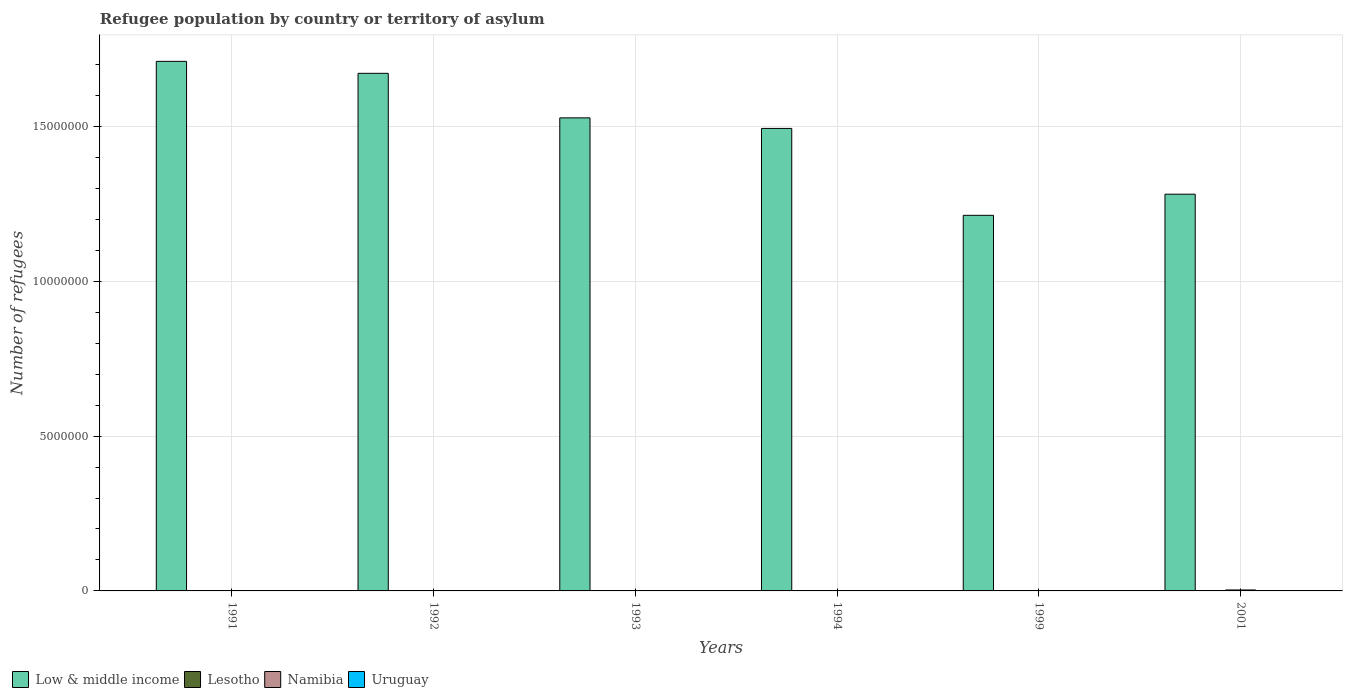Are the number of bars on each tick of the X-axis equal?
Your response must be concise. Yes. How many bars are there on the 1st tick from the left?
Give a very brief answer. 4. How many bars are there on the 3rd tick from the right?
Make the answer very short. 4. What is the label of the 3rd group of bars from the left?
Make the answer very short. 1993. In how many cases, is the number of bars for a given year not equal to the number of legend labels?
Your response must be concise. 0. What is the number of refugees in Low & middle income in 1991?
Make the answer very short. 1.71e+07. Across all years, what is the maximum number of refugees in Uruguay?
Your response must be concise. 138. Across all years, what is the minimum number of refugees in Low & middle income?
Provide a short and direct response. 1.21e+07. In which year was the number of refugees in Namibia maximum?
Your answer should be compact. 2001. In which year was the number of refugees in Low & middle income minimum?
Ensure brevity in your answer.  1999. What is the total number of refugees in Low & middle income in the graph?
Your answer should be very brief. 8.90e+07. What is the difference between the number of refugees in Uruguay in 1993 and that in 1994?
Ensure brevity in your answer.  25. What is the difference between the number of refugees in Low & middle income in 2001 and the number of refugees in Namibia in 1991?
Provide a short and direct response. 1.28e+07. What is the average number of refugees in Lesotho per year?
Give a very brief answer. 82.5. In the year 1993, what is the difference between the number of refugees in Namibia and number of refugees in Low & middle income?
Keep it short and to the point. -1.53e+07. In how many years, is the number of refugees in Lesotho greater than 3000000?
Make the answer very short. 0. What is the ratio of the number of refugees in Namibia in 1993 to that in 1999?
Your answer should be very brief. 0.08. Is the number of refugees in Namibia in 1993 less than that in 2001?
Provide a short and direct response. Yes. Is the difference between the number of refugees in Namibia in 1993 and 1999 greater than the difference between the number of refugees in Low & middle income in 1993 and 1999?
Offer a terse response. No. What is the difference between the highest and the lowest number of refugees in Uruguay?
Ensure brevity in your answer.  57. Is the sum of the number of refugees in Lesotho in 1992 and 1994 greater than the maximum number of refugees in Low & middle income across all years?
Your response must be concise. No. Is it the case that in every year, the sum of the number of refugees in Namibia and number of refugees in Lesotho is greater than the sum of number of refugees in Uruguay and number of refugees in Low & middle income?
Offer a very short reply. No. What does the 1st bar from the left in 2001 represents?
Keep it short and to the point. Low & middle income. What does the 3rd bar from the right in 1993 represents?
Offer a very short reply. Lesotho. Is it the case that in every year, the sum of the number of refugees in Lesotho and number of refugees in Low & middle income is greater than the number of refugees in Namibia?
Provide a succinct answer. Yes. How many years are there in the graph?
Offer a very short reply. 6. What is the difference between two consecutive major ticks on the Y-axis?
Give a very brief answer. 5.00e+06. Does the graph contain any zero values?
Give a very brief answer. No. What is the title of the graph?
Your answer should be very brief. Refugee population by country or territory of asylum. Does "United States" appear as one of the legend labels in the graph?
Keep it short and to the point. No. What is the label or title of the X-axis?
Give a very brief answer. Years. What is the label or title of the Y-axis?
Keep it short and to the point. Number of refugees. What is the Number of refugees in Low & middle income in 1991?
Offer a terse response. 1.71e+07. What is the Number of refugees in Lesotho in 1991?
Your answer should be very brief. 220. What is the Number of refugees in Namibia in 1991?
Ensure brevity in your answer.  136. What is the Number of refugees of Low & middle income in 1992?
Your response must be concise. 1.67e+07. What is the Number of refugees of Lesotho in 1992?
Your answer should be very brief. 117. What is the Number of refugees of Namibia in 1992?
Provide a short and direct response. 171. What is the Number of refugees in Uruguay in 1992?
Offer a terse response. 90. What is the Number of refugees of Low & middle income in 1993?
Make the answer very short. 1.53e+07. What is the Number of refugees in Namibia in 1993?
Give a very brief answer. 585. What is the Number of refugees in Uruguay in 1993?
Provide a short and direct response. 138. What is the Number of refugees of Low & middle income in 1994?
Make the answer very short. 1.49e+07. What is the Number of refugees in Namibia in 1994?
Ensure brevity in your answer.  1144. What is the Number of refugees in Uruguay in 1994?
Provide a short and direct response. 113. What is the Number of refugees in Low & middle income in 1999?
Give a very brief answer. 1.21e+07. What is the Number of refugees of Lesotho in 1999?
Provide a short and direct response. 1. What is the Number of refugees of Namibia in 1999?
Offer a very short reply. 7612. What is the Number of refugees in Uruguay in 1999?
Keep it short and to the point. 87. What is the Number of refugees of Low & middle income in 2001?
Provide a succinct answer. 1.28e+07. What is the Number of refugees of Lesotho in 2001?
Keep it short and to the point. 39. What is the Number of refugees in Namibia in 2001?
Offer a very short reply. 3.09e+04. What is the Number of refugees in Uruguay in 2001?
Make the answer very short. 90. Across all years, what is the maximum Number of refugees of Low & middle income?
Keep it short and to the point. 1.71e+07. Across all years, what is the maximum Number of refugees of Lesotho?
Provide a short and direct response. 220. Across all years, what is the maximum Number of refugees of Namibia?
Offer a very short reply. 3.09e+04. Across all years, what is the maximum Number of refugees of Uruguay?
Offer a very short reply. 138. Across all years, what is the minimum Number of refugees in Low & middle income?
Ensure brevity in your answer.  1.21e+07. Across all years, what is the minimum Number of refugees of Lesotho?
Provide a succinct answer. 1. Across all years, what is the minimum Number of refugees in Namibia?
Provide a short and direct response. 136. What is the total Number of refugees in Low & middle income in the graph?
Offer a very short reply. 8.90e+07. What is the total Number of refugees of Lesotho in the graph?
Make the answer very short. 495. What is the total Number of refugees in Namibia in the graph?
Keep it short and to the point. 4.05e+04. What is the total Number of refugees in Uruguay in the graph?
Your response must be concise. 599. What is the difference between the Number of refugees in Low & middle income in 1991 and that in 1992?
Your answer should be compact. 3.87e+05. What is the difference between the Number of refugees of Lesotho in 1991 and that in 1992?
Your answer should be compact. 103. What is the difference between the Number of refugees in Namibia in 1991 and that in 1992?
Ensure brevity in your answer.  -35. What is the difference between the Number of refugees in Uruguay in 1991 and that in 1992?
Keep it short and to the point. -9. What is the difference between the Number of refugees of Low & middle income in 1991 and that in 1993?
Your answer should be very brief. 1.82e+06. What is the difference between the Number of refugees of Lesotho in 1991 and that in 1993?
Your answer should be very brief. 160. What is the difference between the Number of refugees in Namibia in 1991 and that in 1993?
Your answer should be compact. -449. What is the difference between the Number of refugees in Uruguay in 1991 and that in 1993?
Your answer should be very brief. -57. What is the difference between the Number of refugees of Low & middle income in 1991 and that in 1994?
Make the answer very short. 2.17e+06. What is the difference between the Number of refugees of Lesotho in 1991 and that in 1994?
Offer a very short reply. 162. What is the difference between the Number of refugees of Namibia in 1991 and that in 1994?
Provide a short and direct response. -1008. What is the difference between the Number of refugees in Uruguay in 1991 and that in 1994?
Your answer should be compact. -32. What is the difference between the Number of refugees of Low & middle income in 1991 and that in 1999?
Your response must be concise. 4.97e+06. What is the difference between the Number of refugees of Lesotho in 1991 and that in 1999?
Give a very brief answer. 219. What is the difference between the Number of refugees of Namibia in 1991 and that in 1999?
Offer a very short reply. -7476. What is the difference between the Number of refugees in Uruguay in 1991 and that in 1999?
Make the answer very short. -6. What is the difference between the Number of refugees in Low & middle income in 1991 and that in 2001?
Provide a short and direct response. 4.29e+06. What is the difference between the Number of refugees of Lesotho in 1991 and that in 2001?
Ensure brevity in your answer.  181. What is the difference between the Number of refugees of Namibia in 1991 and that in 2001?
Your answer should be compact. -3.07e+04. What is the difference between the Number of refugees of Uruguay in 1991 and that in 2001?
Keep it short and to the point. -9. What is the difference between the Number of refugees of Low & middle income in 1992 and that in 1993?
Provide a short and direct response. 1.44e+06. What is the difference between the Number of refugees of Lesotho in 1992 and that in 1993?
Make the answer very short. 57. What is the difference between the Number of refugees of Namibia in 1992 and that in 1993?
Ensure brevity in your answer.  -414. What is the difference between the Number of refugees in Uruguay in 1992 and that in 1993?
Give a very brief answer. -48. What is the difference between the Number of refugees in Low & middle income in 1992 and that in 1994?
Provide a succinct answer. 1.78e+06. What is the difference between the Number of refugees in Namibia in 1992 and that in 1994?
Provide a short and direct response. -973. What is the difference between the Number of refugees in Low & middle income in 1992 and that in 1999?
Provide a succinct answer. 4.59e+06. What is the difference between the Number of refugees of Lesotho in 1992 and that in 1999?
Provide a short and direct response. 116. What is the difference between the Number of refugees in Namibia in 1992 and that in 1999?
Your response must be concise. -7441. What is the difference between the Number of refugees in Low & middle income in 1992 and that in 2001?
Make the answer very short. 3.90e+06. What is the difference between the Number of refugees in Namibia in 1992 and that in 2001?
Make the answer very short. -3.07e+04. What is the difference between the Number of refugees in Low & middle income in 1993 and that in 1994?
Your answer should be compact. 3.41e+05. What is the difference between the Number of refugees in Lesotho in 1993 and that in 1994?
Your response must be concise. 2. What is the difference between the Number of refugees of Namibia in 1993 and that in 1994?
Provide a short and direct response. -559. What is the difference between the Number of refugees of Uruguay in 1993 and that in 1994?
Your answer should be compact. 25. What is the difference between the Number of refugees in Low & middle income in 1993 and that in 1999?
Offer a terse response. 3.15e+06. What is the difference between the Number of refugees in Lesotho in 1993 and that in 1999?
Your response must be concise. 59. What is the difference between the Number of refugees in Namibia in 1993 and that in 1999?
Offer a terse response. -7027. What is the difference between the Number of refugees in Low & middle income in 1993 and that in 2001?
Keep it short and to the point. 2.46e+06. What is the difference between the Number of refugees in Lesotho in 1993 and that in 2001?
Ensure brevity in your answer.  21. What is the difference between the Number of refugees of Namibia in 1993 and that in 2001?
Your response must be concise. -3.03e+04. What is the difference between the Number of refugees of Low & middle income in 1994 and that in 1999?
Your response must be concise. 2.81e+06. What is the difference between the Number of refugees of Lesotho in 1994 and that in 1999?
Your answer should be compact. 57. What is the difference between the Number of refugees of Namibia in 1994 and that in 1999?
Give a very brief answer. -6468. What is the difference between the Number of refugees in Uruguay in 1994 and that in 1999?
Make the answer very short. 26. What is the difference between the Number of refugees in Low & middle income in 1994 and that in 2001?
Ensure brevity in your answer.  2.12e+06. What is the difference between the Number of refugees of Namibia in 1994 and that in 2001?
Make the answer very short. -2.97e+04. What is the difference between the Number of refugees of Low & middle income in 1999 and that in 2001?
Offer a very short reply. -6.82e+05. What is the difference between the Number of refugees in Lesotho in 1999 and that in 2001?
Offer a terse response. -38. What is the difference between the Number of refugees in Namibia in 1999 and that in 2001?
Provide a short and direct response. -2.33e+04. What is the difference between the Number of refugees in Low & middle income in 1991 and the Number of refugees in Lesotho in 1992?
Keep it short and to the point. 1.71e+07. What is the difference between the Number of refugees of Low & middle income in 1991 and the Number of refugees of Namibia in 1992?
Your response must be concise. 1.71e+07. What is the difference between the Number of refugees of Low & middle income in 1991 and the Number of refugees of Uruguay in 1992?
Ensure brevity in your answer.  1.71e+07. What is the difference between the Number of refugees of Lesotho in 1991 and the Number of refugees of Uruguay in 1992?
Offer a very short reply. 130. What is the difference between the Number of refugees in Low & middle income in 1991 and the Number of refugees in Lesotho in 1993?
Offer a very short reply. 1.71e+07. What is the difference between the Number of refugees in Low & middle income in 1991 and the Number of refugees in Namibia in 1993?
Give a very brief answer. 1.71e+07. What is the difference between the Number of refugees of Low & middle income in 1991 and the Number of refugees of Uruguay in 1993?
Your answer should be very brief. 1.71e+07. What is the difference between the Number of refugees of Lesotho in 1991 and the Number of refugees of Namibia in 1993?
Your response must be concise. -365. What is the difference between the Number of refugees of Lesotho in 1991 and the Number of refugees of Uruguay in 1993?
Offer a terse response. 82. What is the difference between the Number of refugees in Low & middle income in 1991 and the Number of refugees in Lesotho in 1994?
Your answer should be compact. 1.71e+07. What is the difference between the Number of refugees of Low & middle income in 1991 and the Number of refugees of Namibia in 1994?
Your answer should be very brief. 1.71e+07. What is the difference between the Number of refugees in Low & middle income in 1991 and the Number of refugees in Uruguay in 1994?
Your response must be concise. 1.71e+07. What is the difference between the Number of refugees in Lesotho in 1991 and the Number of refugees in Namibia in 1994?
Keep it short and to the point. -924. What is the difference between the Number of refugees in Lesotho in 1991 and the Number of refugees in Uruguay in 1994?
Offer a very short reply. 107. What is the difference between the Number of refugees of Low & middle income in 1991 and the Number of refugees of Lesotho in 1999?
Keep it short and to the point. 1.71e+07. What is the difference between the Number of refugees in Low & middle income in 1991 and the Number of refugees in Namibia in 1999?
Your response must be concise. 1.71e+07. What is the difference between the Number of refugees in Low & middle income in 1991 and the Number of refugees in Uruguay in 1999?
Offer a terse response. 1.71e+07. What is the difference between the Number of refugees in Lesotho in 1991 and the Number of refugees in Namibia in 1999?
Offer a terse response. -7392. What is the difference between the Number of refugees of Lesotho in 1991 and the Number of refugees of Uruguay in 1999?
Provide a short and direct response. 133. What is the difference between the Number of refugees of Namibia in 1991 and the Number of refugees of Uruguay in 1999?
Provide a short and direct response. 49. What is the difference between the Number of refugees of Low & middle income in 1991 and the Number of refugees of Lesotho in 2001?
Keep it short and to the point. 1.71e+07. What is the difference between the Number of refugees in Low & middle income in 1991 and the Number of refugees in Namibia in 2001?
Offer a terse response. 1.71e+07. What is the difference between the Number of refugees in Low & middle income in 1991 and the Number of refugees in Uruguay in 2001?
Offer a terse response. 1.71e+07. What is the difference between the Number of refugees in Lesotho in 1991 and the Number of refugees in Namibia in 2001?
Offer a very short reply. -3.07e+04. What is the difference between the Number of refugees of Lesotho in 1991 and the Number of refugees of Uruguay in 2001?
Keep it short and to the point. 130. What is the difference between the Number of refugees of Namibia in 1991 and the Number of refugees of Uruguay in 2001?
Ensure brevity in your answer.  46. What is the difference between the Number of refugees in Low & middle income in 1992 and the Number of refugees in Lesotho in 1993?
Make the answer very short. 1.67e+07. What is the difference between the Number of refugees of Low & middle income in 1992 and the Number of refugees of Namibia in 1993?
Your response must be concise. 1.67e+07. What is the difference between the Number of refugees of Low & middle income in 1992 and the Number of refugees of Uruguay in 1993?
Your answer should be compact. 1.67e+07. What is the difference between the Number of refugees in Lesotho in 1992 and the Number of refugees in Namibia in 1993?
Provide a succinct answer. -468. What is the difference between the Number of refugees of Low & middle income in 1992 and the Number of refugees of Lesotho in 1994?
Make the answer very short. 1.67e+07. What is the difference between the Number of refugees of Low & middle income in 1992 and the Number of refugees of Namibia in 1994?
Offer a terse response. 1.67e+07. What is the difference between the Number of refugees in Low & middle income in 1992 and the Number of refugees in Uruguay in 1994?
Ensure brevity in your answer.  1.67e+07. What is the difference between the Number of refugees in Lesotho in 1992 and the Number of refugees in Namibia in 1994?
Offer a terse response. -1027. What is the difference between the Number of refugees in Low & middle income in 1992 and the Number of refugees in Lesotho in 1999?
Make the answer very short. 1.67e+07. What is the difference between the Number of refugees of Low & middle income in 1992 and the Number of refugees of Namibia in 1999?
Keep it short and to the point. 1.67e+07. What is the difference between the Number of refugees of Low & middle income in 1992 and the Number of refugees of Uruguay in 1999?
Offer a terse response. 1.67e+07. What is the difference between the Number of refugees of Lesotho in 1992 and the Number of refugees of Namibia in 1999?
Keep it short and to the point. -7495. What is the difference between the Number of refugees of Namibia in 1992 and the Number of refugees of Uruguay in 1999?
Your answer should be compact. 84. What is the difference between the Number of refugees in Low & middle income in 1992 and the Number of refugees in Lesotho in 2001?
Ensure brevity in your answer.  1.67e+07. What is the difference between the Number of refugees of Low & middle income in 1992 and the Number of refugees of Namibia in 2001?
Keep it short and to the point. 1.67e+07. What is the difference between the Number of refugees in Low & middle income in 1992 and the Number of refugees in Uruguay in 2001?
Keep it short and to the point. 1.67e+07. What is the difference between the Number of refugees of Lesotho in 1992 and the Number of refugees of Namibia in 2001?
Provide a succinct answer. -3.08e+04. What is the difference between the Number of refugees of Namibia in 1992 and the Number of refugees of Uruguay in 2001?
Your answer should be compact. 81. What is the difference between the Number of refugees of Low & middle income in 1993 and the Number of refugees of Lesotho in 1994?
Your answer should be very brief. 1.53e+07. What is the difference between the Number of refugees in Low & middle income in 1993 and the Number of refugees in Namibia in 1994?
Make the answer very short. 1.53e+07. What is the difference between the Number of refugees in Low & middle income in 1993 and the Number of refugees in Uruguay in 1994?
Provide a succinct answer. 1.53e+07. What is the difference between the Number of refugees of Lesotho in 1993 and the Number of refugees of Namibia in 1994?
Provide a short and direct response. -1084. What is the difference between the Number of refugees in Lesotho in 1993 and the Number of refugees in Uruguay in 1994?
Provide a succinct answer. -53. What is the difference between the Number of refugees in Namibia in 1993 and the Number of refugees in Uruguay in 1994?
Keep it short and to the point. 472. What is the difference between the Number of refugees in Low & middle income in 1993 and the Number of refugees in Lesotho in 1999?
Keep it short and to the point. 1.53e+07. What is the difference between the Number of refugees of Low & middle income in 1993 and the Number of refugees of Namibia in 1999?
Make the answer very short. 1.53e+07. What is the difference between the Number of refugees of Low & middle income in 1993 and the Number of refugees of Uruguay in 1999?
Make the answer very short. 1.53e+07. What is the difference between the Number of refugees in Lesotho in 1993 and the Number of refugees in Namibia in 1999?
Offer a terse response. -7552. What is the difference between the Number of refugees in Namibia in 1993 and the Number of refugees in Uruguay in 1999?
Ensure brevity in your answer.  498. What is the difference between the Number of refugees in Low & middle income in 1993 and the Number of refugees in Lesotho in 2001?
Provide a short and direct response. 1.53e+07. What is the difference between the Number of refugees of Low & middle income in 1993 and the Number of refugees of Namibia in 2001?
Offer a very short reply. 1.52e+07. What is the difference between the Number of refugees in Low & middle income in 1993 and the Number of refugees in Uruguay in 2001?
Ensure brevity in your answer.  1.53e+07. What is the difference between the Number of refugees in Lesotho in 1993 and the Number of refugees in Namibia in 2001?
Provide a succinct answer. -3.08e+04. What is the difference between the Number of refugees in Namibia in 1993 and the Number of refugees in Uruguay in 2001?
Your response must be concise. 495. What is the difference between the Number of refugees of Low & middle income in 1994 and the Number of refugees of Lesotho in 1999?
Offer a very short reply. 1.49e+07. What is the difference between the Number of refugees of Low & middle income in 1994 and the Number of refugees of Namibia in 1999?
Provide a succinct answer. 1.49e+07. What is the difference between the Number of refugees of Low & middle income in 1994 and the Number of refugees of Uruguay in 1999?
Give a very brief answer. 1.49e+07. What is the difference between the Number of refugees of Lesotho in 1994 and the Number of refugees of Namibia in 1999?
Your answer should be very brief. -7554. What is the difference between the Number of refugees of Lesotho in 1994 and the Number of refugees of Uruguay in 1999?
Give a very brief answer. -29. What is the difference between the Number of refugees of Namibia in 1994 and the Number of refugees of Uruguay in 1999?
Make the answer very short. 1057. What is the difference between the Number of refugees in Low & middle income in 1994 and the Number of refugees in Lesotho in 2001?
Your response must be concise. 1.49e+07. What is the difference between the Number of refugees of Low & middle income in 1994 and the Number of refugees of Namibia in 2001?
Offer a terse response. 1.49e+07. What is the difference between the Number of refugees in Low & middle income in 1994 and the Number of refugees in Uruguay in 2001?
Give a very brief answer. 1.49e+07. What is the difference between the Number of refugees of Lesotho in 1994 and the Number of refugees of Namibia in 2001?
Provide a short and direct response. -3.08e+04. What is the difference between the Number of refugees in Lesotho in 1994 and the Number of refugees in Uruguay in 2001?
Keep it short and to the point. -32. What is the difference between the Number of refugees of Namibia in 1994 and the Number of refugees of Uruguay in 2001?
Your answer should be very brief. 1054. What is the difference between the Number of refugees in Low & middle income in 1999 and the Number of refugees in Lesotho in 2001?
Ensure brevity in your answer.  1.21e+07. What is the difference between the Number of refugees in Low & middle income in 1999 and the Number of refugees in Namibia in 2001?
Your response must be concise. 1.21e+07. What is the difference between the Number of refugees of Low & middle income in 1999 and the Number of refugees of Uruguay in 2001?
Provide a succinct answer. 1.21e+07. What is the difference between the Number of refugees of Lesotho in 1999 and the Number of refugees of Namibia in 2001?
Provide a short and direct response. -3.09e+04. What is the difference between the Number of refugees in Lesotho in 1999 and the Number of refugees in Uruguay in 2001?
Provide a short and direct response. -89. What is the difference between the Number of refugees in Namibia in 1999 and the Number of refugees in Uruguay in 2001?
Keep it short and to the point. 7522. What is the average Number of refugees in Low & middle income per year?
Make the answer very short. 1.48e+07. What is the average Number of refugees of Lesotho per year?
Your answer should be very brief. 82.5. What is the average Number of refugees of Namibia per year?
Your answer should be compact. 6755.5. What is the average Number of refugees in Uruguay per year?
Provide a succinct answer. 99.83. In the year 1991, what is the difference between the Number of refugees of Low & middle income and Number of refugees of Lesotho?
Make the answer very short. 1.71e+07. In the year 1991, what is the difference between the Number of refugees of Low & middle income and Number of refugees of Namibia?
Provide a succinct answer. 1.71e+07. In the year 1991, what is the difference between the Number of refugees of Low & middle income and Number of refugees of Uruguay?
Provide a short and direct response. 1.71e+07. In the year 1991, what is the difference between the Number of refugees in Lesotho and Number of refugees in Uruguay?
Keep it short and to the point. 139. In the year 1991, what is the difference between the Number of refugees of Namibia and Number of refugees of Uruguay?
Ensure brevity in your answer.  55. In the year 1992, what is the difference between the Number of refugees of Low & middle income and Number of refugees of Lesotho?
Ensure brevity in your answer.  1.67e+07. In the year 1992, what is the difference between the Number of refugees in Low & middle income and Number of refugees in Namibia?
Offer a terse response. 1.67e+07. In the year 1992, what is the difference between the Number of refugees of Low & middle income and Number of refugees of Uruguay?
Ensure brevity in your answer.  1.67e+07. In the year 1992, what is the difference between the Number of refugees in Lesotho and Number of refugees in Namibia?
Give a very brief answer. -54. In the year 1992, what is the difference between the Number of refugees of Lesotho and Number of refugees of Uruguay?
Offer a very short reply. 27. In the year 1993, what is the difference between the Number of refugees in Low & middle income and Number of refugees in Lesotho?
Keep it short and to the point. 1.53e+07. In the year 1993, what is the difference between the Number of refugees in Low & middle income and Number of refugees in Namibia?
Provide a short and direct response. 1.53e+07. In the year 1993, what is the difference between the Number of refugees in Low & middle income and Number of refugees in Uruguay?
Ensure brevity in your answer.  1.53e+07. In the year 1993, what is the difference between the Number of refugees in Lesotho and Number of refugees in Namibia?
Give a very brief answer. -525. In the year 1993, what is the difference between the Number of refugees in Lesotho and Number of refugees in Uruguay?
Offer a terse response. -78. In the year 1993, what is the difference between the Number of refugees of Namibia and Number of refugees of Uruguay?
Your answer should be compact. 447. In the year 1994, what is the difference between the Number of refugees in Low & middle income and Number of refugees in Lesotho?
Your response must be concise. 1.49e+07. In the year 1994, what is the difference between the Number of refugees in Low & middle income and Number of refugees in Namibia?
Offer a terse response. 1.49e+07. In the year 1994, what is the difference between the Number of refugees of Low & middle income and Number of refugees of Uruguay?
Ensure brevity in your answer.  1.49e+07. In the year 1994, what is the difference between the Number of refugees of Lesotho and Number of refugees of Namibia?
Your response must be concise. -1086. In the year 1994, what is the difference between the Number of refugees in Lesotho and Number of refugees in Uruguay?
Offer a terse response. -55. In the year 1994, what is the difference between the Number of refugees of Namibia and Number of refugees of Uruguay?
Offer a very short reply. 1031. In the year 1999, what is the difference between the Number of refugees of Low & middle income and Number of refugees of Lesotho?
Ensure brevity in your answer.  1.21e+07. In the year 1999, what is the difference between the Number of refugees of Low & middle income and Number of refugees of Namibia?
Your answer should be very brief. 1.21e+07. In the year 1999, what is the difference between the Number of refugees of Low & middle income and Number of refugees of Uruguay?
Keep it short and to the point. 1.21e+07. In the year 1999, what is the difference between the Number of refugees in Lesotho and Number of refugees in Namibia?
Provide a short and direct response. -7611. In the year 1999, what is the difference between the Number of refugees of Lesotho and Number of refugees of Uruguay?
Your answer should be very brief. -86. In the year 1999, what is the difference between the Number of refugees in Namibia and Number of refugees in Uruguay?
Offer a very short reply. 7525. In the year 2001, what is the difference between the Number of refugees of Low & middle income and Number of refugees of Lesotho?
Offer a terse response. 1.28e+07. In the year 2001, what is the difference between the Number of refugees in Low & middle income and Number of refugees in Namibia?
Offer a terse response. 1.28e+07. In the year 2001, what is the difference between the Number of refugees in Low & middle income and Number of refugees in Uruguay?
Offer a terse response. 1.28e+07. In the year 2001, what is the difference between the Number of refugees of Lesotho and Number of refugees of Namibia?
Give a very brief answer. -3.08e+04. In the year 2001, what is the difference between the Number of refugees of Lesotho and Number of refugees of Uruguay?
Give a very brief answer. -51. In the year 2001, what is the difference between the Number of refugees in Namibia and Number of refugees in Uruguay?
Offer a very short reply. 3.08e+04. What is the ratio of the Number of refugees in Low & middle income in 1991 to that in 1992?
Your answer should be very brief. 1.02. What is the ratio of the Number of refugees of Lesotho in 1991 to that in 1992?
Give a very brief answer. 1.88. What is the ratio of the Number of refugees in Namibia in 1991 to that in 1992?
Keep it short and to the point. 0.8. What is the ratio of the Number of refugees of Low & middle income in 1991 to that in 1993?
Your answer should be compact. 1.12. What is the ratio of the Number of refugees in Lesotho in 1991 to that in 1993?
Make the answer very short. 3.67. What is the ratio of the Number of refugees in Namibia in 1991 to that in 1993?
Provide a succinct answer. 0.23. What is the ratio of the Number of refugees in Uruguay in 1991 to that in 1993?
Offer a terse response. 0.59. What is the ratio of the Number of refugees in Low & middle income in 1991 to that in 1994?
Offer a terse response. 1.15. What is the ratio of the Number of refugees of Lesotho in 1991 to that in 1994?
Your response must be concise. 3.79. What is the ratio of the Number of refugees in Namibia in 1991 to that in 1994?
Make the answer very short. 0.12. What is the ratio of the Number of refugees in Uruguay in 1991 to that in 1994?
Provide a short and direct response. 0.72. What is the ratio of the Number of refugees in Low & middle income in 1991 to that in 1999?
Provide a succinct answer. 1.41. What is the ratio of the Number of refugees of Lesotho in 1991 to that in 1999?
Make the answer very short. 220. What is the ratio of the Number of refugees in Namibia in 1991 to that in 1999?
Your response must be concise. 0.02. What is the ratio of the Number of refugees of Uruguay in 1991 to that in 1999?
Keep it short and to the point. 0.93. What is the ratio of the Number of refugees in Low & middle income in 1991 to that in 2001?
Provide a short and direct response. 1.33. What is the ratio of the Number of refugees of Lesotho in 1991 to that in 2001?
Give a very brief answer. 5.64. What is the ratio of the Number of refugees of Namibia in 1991 to that in 2001?
Your answer should be very brief. 0. What is the ratio of the Number of refugees in Low & middle income in 1992 to that in 1993?
Make the answer very short. 1.09. What is the ratio of the Number of refugees of Lesotho in 1992 to that in 1993?
Offer a very short reply. 1.95. What is the ratio of the Number of refugees in Namibia in 1992 to that in 1993?
Your response must be concise. 0.29. What is the ratio of the Number of refugees in Uruguay in 1992 to that in 1993?
Provide a succinct answer. 0.65. What is the ratio of the Number of refugees of Low & middle income in 1992 to that in 1994?
Make the answer very short. 1.12. What is the ratio of the Number of refugees in Lesotho in 1992 to that in 1994?
Provide a short and direct response. 2.02. What is the ratio of the Number of refugees of Namibia in 1992 to that in 1994?
Keep it short and to the point. 0.15. What is the ratio of the Number of refugees in Uruguay in 1992 to that in 1994?
Your response must be concise. 0.8. What is the ratio of the Number of refugees of Low & middle income in 1992 to that in 1999?
Keep it short and to the point. 1.38. What is the ratio of the Number of refugees in Lesotho in 1992 to that in 1999?
Offer a very short reply. 117. What is the ratio of the Number of refugees of Namibia in 1992 to that in 1999?
Give a very brief answer. 0.02. What is the ratio of the Number of refugees of Uruguay in 1992 to that in 1999?
Provide a short and direct response. 1.03. What is the ratio of the Number of refugees in Low & middle income in 1992 to that in 2001?
Ensure brevity in your answer.  1.3. What is the ratio of the Number of refugees in Lesotho in 1992 to that in 2001?
Give a very brief answer. 3. What is the ratio of the Number of refugees in Namibia in 1992 to that in 2001?
Your answer should be compact. 0.01. What is the ratio of the Number of refugees in Uruguay in 1992 to that in 2001?
Ensure brevity in your answer.  1. What is the ratio of the Number of refugees of Low & middle income in 1993 to that in 1994?
Offer a terse response. 1.02. What is the ratio of the Number of refugees of Lesotho in 1993 to that in 1994?
Provide a succinct answer. 1.03. What is the ratio of the Number of refugees of Namibia in 1993 to that in 1994?
Your answer should be very brief. 0.51. What is the ratio of the Number of refugees in Uruguay in 1993 to that in 1994?
Offer a very short reply. 1.22. What is the ratio of the Number of refugees in Low & middle income in 1993 to that in 1999?
Your answer should be very brief. 1.26. What is the ratio of the Number of refugees of Namibia in 1993 to that in 1999?
Your answer should be compact. 0.08. What is the ratio of the Number of refugees in Uruguay in 1993 to that in 1999?
Offer a very short reply. 1.59. What is the ratio of the Number of refugees in Low & middle income in 1993 to that in 2001?
Your response must be concise. 1.19. What is the ratio of the Number of refugees in Lesotho in 1993 to that in 2001?
Make the answer very short. 1.54. What is the ratio of the Number of refugees of Namibia in 1993 to that in 2001?
Your answer should be compact. 0.02. What is the ratio of the Number of refugees in Uruguay in 1993 to that in 2001?
Offer a terse response. 1.53. What is the ratio of the Number of refugees in Low & middle income in 1994 to that in 1999?
Make the answer very short. 1.23. What is the ratio of the Number of refugees in Lesotho in 1994 to that in 1999?
Offer a very short reply. 58. What is the ratio of the Number of refugees in Namibia in 1994 to that in 1999?
Give a very brief answer. 0.15. What is the ratio of the Number of refugees of Uruguay in 1994 to that in 1999?
Keep it short and to the point. 1.3. What is the ratio of the Number of refugees in Low & middle income in 1994 to that in 2001?
Your answer should be compact. 1.17. What is the ratio of the Number of refugees of Lesotho in 1994 to that in 2001?
Offer a very short reply. 1.49. What is the ratio of the Number of refugees in Namibia in 1994 to that in 2001?
Give a very brief answer. 0.04. What is the ratio of the Number of refugees in Uruguay in 1994 to that in 2001?
Provide a short and direct response. 1.26. What is the ratio of the Number of refugees of Low & middle income in 1999 to that in 2001?
Give a very brief answer. 0.95. What is the ratio of the Number of refugees in Lesotho in 1999 to that in 2001?
Provide a short and direct response. 0.03. What is the ratio of the Number of refugees in Namibia in 1999 to that in 2001?
Offer a very short reply. 0.25. What is the ratio of the Number of refugees of Uruguay in 1999 to that in 2001?
Keep it short and to the point. 0.97. What is the difference between the highest and the second highest Number of refugees of Low & middle income?
Provide a short and direct response. 3.87e+05. What is the difference between the highest and the second highest Number of refugees of Lesotho?
Your answer should be compact. 103. What is the difference between the highest and the second highest Number of refugees in Namibia?
Offer a terse response. 2.33e+04. What is the difference between the highest and the lowest Number of refugees of Low & middle income?
Keep it short and to the point. 4.97e+06. What is the difference between the highest and the lowest Number of refugees of Lesotho?
Your answer should be very brief. 219. What is the difference between the highest and the lowest Number of refugees of Namibia?
Your answer should be compact. 3.07e+04. What is the difference between the highest and the lowest Number of refugees in Uruguay?
Offer a terse response. 57. 